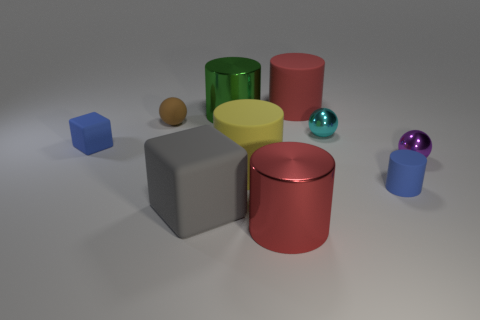Is the size of the block that is in front of the yellow rubber cylinder the same as the blue matte thing that is on the right side of the big green metal cylinder?
Keep it short and to the point. No. What is the color of the metallic object that is on the left side of the thing in front of the gray matte object?
Offer a terse response. Green. What is the material of the brown sphere that is the same size as the cyan metallic ball?
Provide a short and direct response. Rubber. What number of shiny objects are either small yellow spheres or tiny brown balls?
Offer a very short reply. 0. The large rubber object that is to the right of the gray rubber object and in front of the tiny purple shiny ball is what color?
Your answer should be very brief. Yellow. What number of big gray cubes are on the right side of the big yellow thing?
Provide a short and direct response. 0. What is the material of the cyan thing?
Your answer should be compact. Metal. What color is the tiny rubber thing right of the small sphere on the left side of the big matte cylinder behind the matte sphere?
Make the answer very short. Blue. What number of red metal cylinders have the same size as the matte ball?
Offer a terse response. 0. There is a big rubber thing behind the tiny brown rubber object; what is its color?
Offer a terse response. Red. 